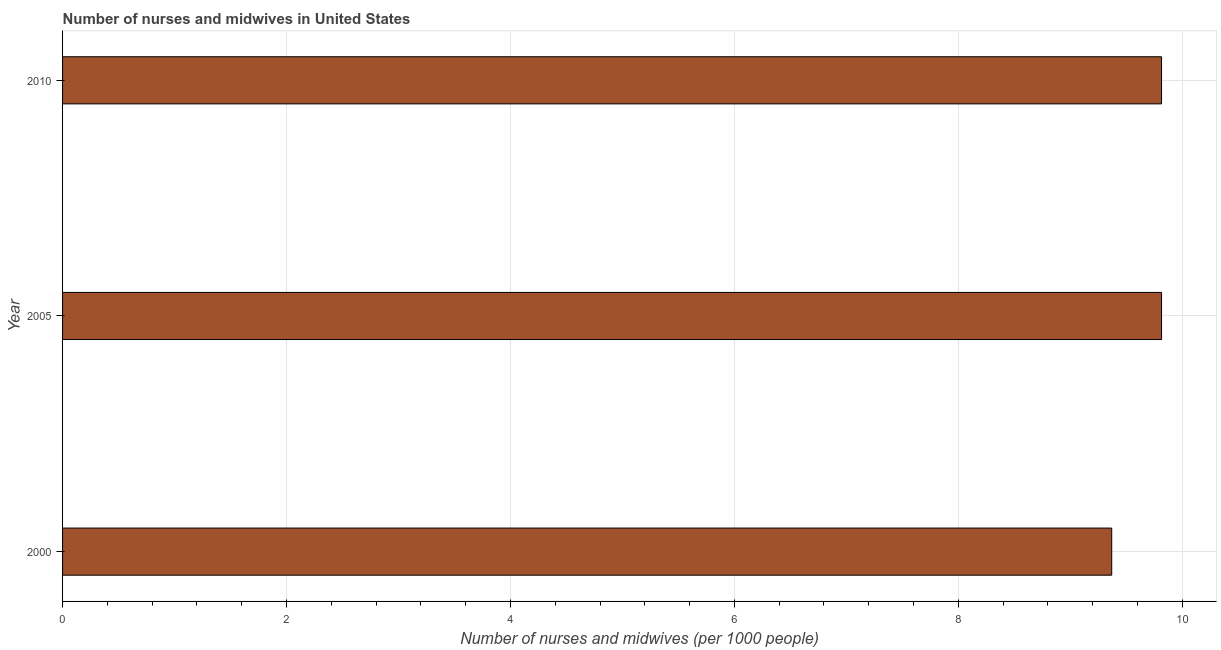Does the graph contain any zero values?
Provide a succinct answer. No. What is the title of the graph?
Your answer should be compact. Number of nurses and midwives in United States. What is the label or title of the X-axis?
Make the answer very short. Number of nurses and midwives (per 1000 people). What is the number of nurses and midwives in 2010?
Your answer should be very brief. 9.81. Across all years, what is the maximum number of nurses and midwives?
Provide a short and direct response. 9.81. Across all years, what is the minimum number of nurses and midwives?
Your answer should be very brief. 9.37. In which year was the number of nurses and midwives maximum?
Your answer should be very brief. 2005. What is the sum of the number of nurses and midwives?
Your response must be concise. 29. What is the difference between the number of nurses and midwives in 2000 and 2010?
Your response must be concise. -0.45. What is the average number of nurses and midwives per year?
Make the answer very short. 9.67. What is the median number of nurses and midwives?
Ensure brevity in your answer.  9.81. In how many years, is the number of nurses and midwives greater than 6 ?
Offer a terse response. 3. What is the ratio of the number of nurses and midwives in 2000 to that in 2005?
Offer a very short reply. 0.95. Is the number of nurses and midwives in 2000 less than that in 2005?
Offer a terse response. Yes. What is the difference between the highest and the second highest number of nurses and midwives?
Keep it short and to the point. 0. What is the difference between the highest and the lowest number of nurses and midwives?
Your answer should be very brief. 0.45. In how many years, is the number of nurses and midwives greater than the average number of nurses and midwives taken over all years?
Offer a terse response. 2. How many bars are there?
Your answer should be very brief. 3. Are all the bars in the graph horizontal?
Ensure brevity in your answer.  Yes. How many years are there in the graph?
Ensure brevity in your answer.  3. Are the values on the major ticks of X-axis written in scientific E-notation?
Make the answer very short. No. What is the Number of nurses and midwives (per 1000 people) of 2000?
Your answer should be very brief. 9.37. What is the Number of nurses and midwives (per 1000 people) of 2005?
Offer a very short reply. 9.81. What is the Number of nurses and midwives (per 1000 people) of 2010?
Your response must be concise. 9.81. What is the difference between the Number of nurses and midwives (per 1000 people) in 2000 and 2005?
Give a very brief answer. -0.45. What is the difference between the Number of nurses and midwives (per 1000 people) in 2000 and 2010?
Provide a short and direct response. -0.45. What is the difference between the Number of nurses and midwives (per 1000 people) in 2005 and 2010?
Give a very brief answer. 0. What is the ratio of the Number of nurses and midwives (per 1000 people) in 2000 to that in 2005?
Your response must be concise. 0.95. What is the ratio of the Number of nurses and midwives (per 1000 people) in 2000 to that in 2010?
Your answer should be compact. 0.95. 